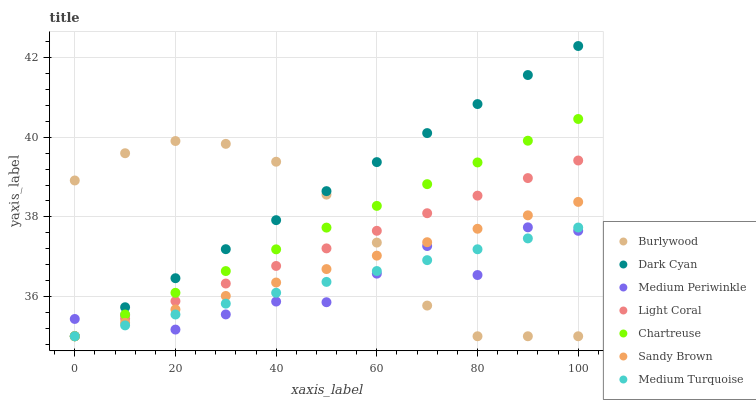Does Medium Periwinkle have the minimum area under the curve?
Answer yes or no. Yes. Does Dark Cyan have the maximum area under the curve?
Answer yes or no. Yes. Does Light Coral have the minimum area under the curve?
Answer yes or no. No. Does Light Coral have the maximum area under the curve?
Answer yes or no. No. Is Light Coral the smoothest?
Answer yes or no. Yes. Is Medium Periwinkle the roughest?
Answer yes or no. Yes. Is Medium Periwinkle the smoothest?
Answer yes or no. No. Is Light Coral the roughest?
Answer yes or no. No. Does Burlywood have the lowest value?
Answer yes or no. Yes. Does Medium Periwinkle have the lowest value?
Answer yes or no. No. Does Dark Cyan have the highest value?
Answer yes or no. Yes. Does Medium Periwinkle have the highest value?
Answer yes or no. No. Does Medium Periwinkle intersect Burlywood?
Answer yes or no. Yes. Is Medium Periwinkle less than Burlywood?
Answer yes or no. No. Is Medium Periwinkle greater than Burlywood?
Answer yes or no. No. 